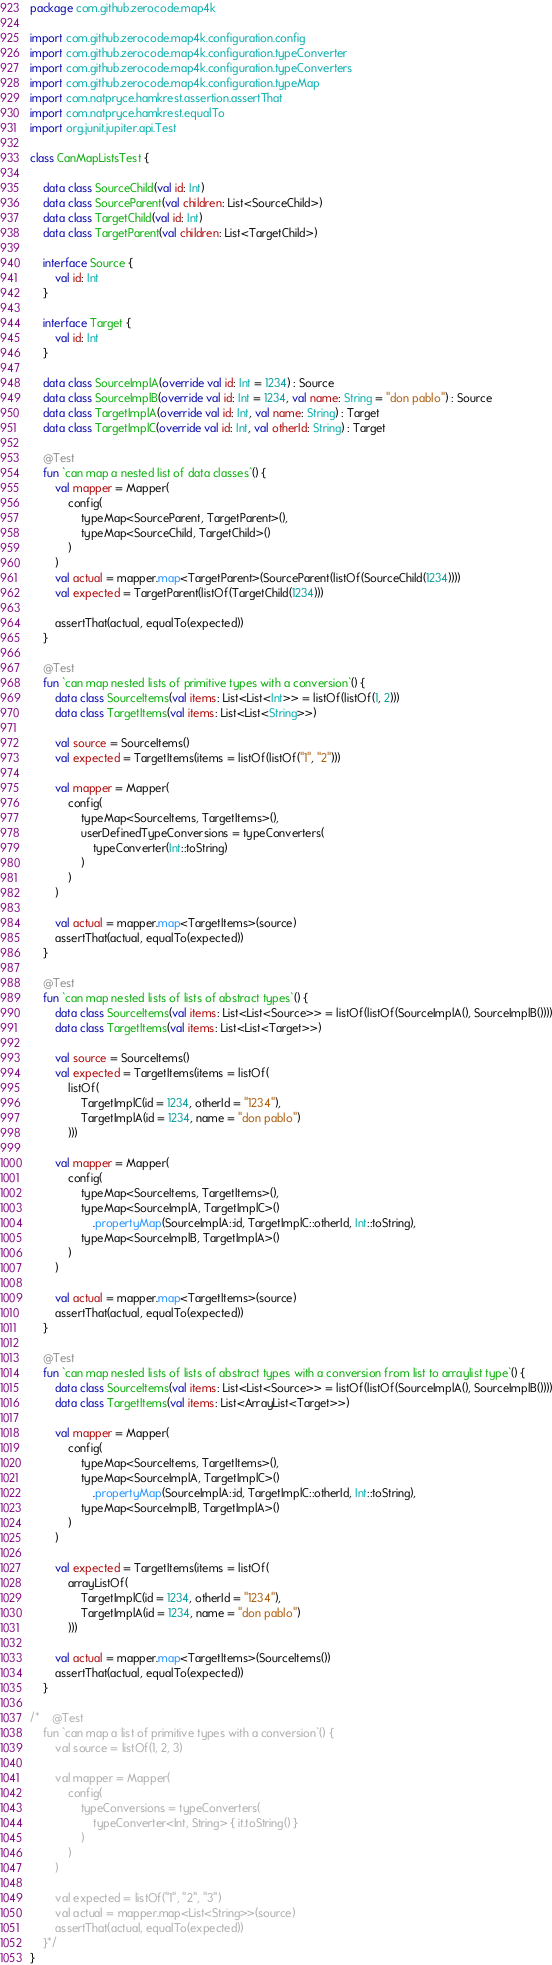Convert code to text. <code><loc_0><loc_0><loc_500><loc_500><_Kotlin_>package com.github.zerocode.map4k

import com.github.zerocode.map4k.configuration.config
import com.github.zerocode.map4k.configuration.typeConverter
import com.github.zerocode.map4k.configuration.typeConverters
import com.github.zerocode.map4k.configuration.typeMap
import com.natpryce.hamkrest.assertion.assertThat
import com.natpryce.hamkrest.equalTo
import org.junit.jupiter.api.Test

class CanMapListsTest {

    data class SourceChild(val id: Int)
    data class SourceParent(val children: List<SourceChild>)
    data class TargetChild(val id: Int)
    data class TargetParent(val children: List<TargetChild>)

    interface Source {
        val id: Int
    }

    interface Target {
        val id: Int
    }

    data class SourceImplA(override val id: Int = 1234) : Source
    data class SourceImplB(override val id: Int = 1234, val name: String = "don pablo") : Source
    data class TargetImplA(override val id: Int, val name: String) : Target
    data class TargetImplC(override val id: Int, val otherId: String) : Target

    @Test
    fun `can map a nested list of data classes`() {
        val mapper = Mapper(
            config(
                typeMap<SourceParent, TargetParent>(),
                typeMap<SourceChild, TargetChild>()
            )
        )
        val actual = mapper.map<TargetParent>(SourceParent(listOf(SourceChild(1234))))
        val expected = TargetParent(listOf(TargetChild(1234)))

        assertThat(actual, equalTo(expected))
    }

    @Test
    fun `can map nested lists of primitive types with a conversion`() {
        data class SourceItems(val items: List<List<Int>> = listOf(listOf(1, 2)))
        data class TargetItems(val items: List<List<String>>)

        val source = SourceItems()
        val expected = TargetItems(items = listOf(listOf("1", "2")))

        val mapper = Mapper(
            config(
                typeMap<SourceItems, TargetItems>(),
                userDefinedTypeConversions = typeConverters(
                    typeConverter(Int::toString)
                )
            )
        )

        val actual = mapper.map<TargetItems>(source)
        assertThat(actual, equalTo(expected))
    }

    @Test
    fun `can map nested lists of lists of abstract types`() {
        data class SourceItems(val items: List<List<Source>> = listOf(listOf(SourceImplA(), SourceImplB())))
        data class TargetItems(val items: List<List<Target>>)

        val source = SourceItems()
        val expected = TargetItems(items = listOf(
            listOf(
                TargetImplC(id = 1234, otherId = "1234"),
                TargetImplA(id = 1234, name = "don pablo")
            )))

        val mapper = Mapper(
            config(
                typeMap<SourceItems, TargetItems>(),
                typeMap<SourceImplA, TargetImplC>()
                    .propertyMap(SourceImplA::id, TargetImplC::otherId, Int::toString),
                typeMap<SourceImplB, TargetImplA>()
            )
        )

        val actual = mapper.map<TargetItems>(source)
        assertThat(actual, equalTo(expected))
    }

    @Test
    fun `can map nested lists of lists of abstract types with a conversion from list to arraylist type`() {
        data class SourceItems(val items: List<List<Source>> = listOf(listOf(SourceImplA(), SourceImplB())))
        data class TargetItems(val items: List<ArrayList<Target>>)

        val mapper = Mapper(
            config(
                typeMap<SourceItems, TargetItems>(),
                typeMap<SourceImplA, TargetImplC>()
                    .propertyMap(SourceImplA::id, TargetImplC::otherId, Int::toString),
                typeMap<SourceImplB, TargetImplA>()
            )
        )

        val expected = TargetItems(items = listOf(
            arrayListOf(
                TargetImplC(id = 1234, otherId = "1234"),
                TargetImplA(id = 1234, name = "don pablo")
            )))

        val actual = mapper.map<TargetItems>(SourceItems())
        assertThat(actual, equalTo(expected))
    }

/*    @Test
    fun `can map a list of primitive types with a conversion`() {
        val source = listOf(1, 2, 3)

        val mapper = Mapper(
            config(
                typeConversions = typeConverters(
                    typeConverter<Int, String> { it.toString() }
                )
            )
        )

        val expected = listOf("1", "2", "3")
        val actual = mapper.map<List<String>>(source)
        assertThat(actual, equalTo(expected))
    }*/
}</code> 